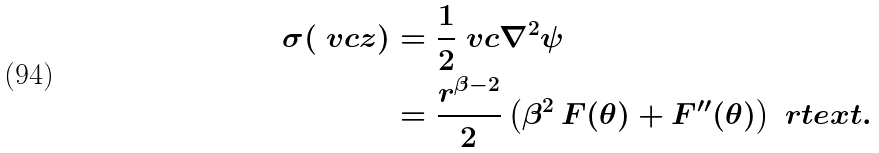Convert formula to latex. <formula><loc_0><loc_0><loc_500><loc_500>\sigma ( \ v c z ) & = \frac { 1 } { 2 } \ v c \nabla ^ { 2 } \psi \\ & = \frac { r ^ { \beta - 2 } } { 2 } \left ( \beta ^ { 2 } \, F ( \theta ) + F ^ { \prime \prime } ( \theta ) \right ) \ r t e x t { . }</formula> 